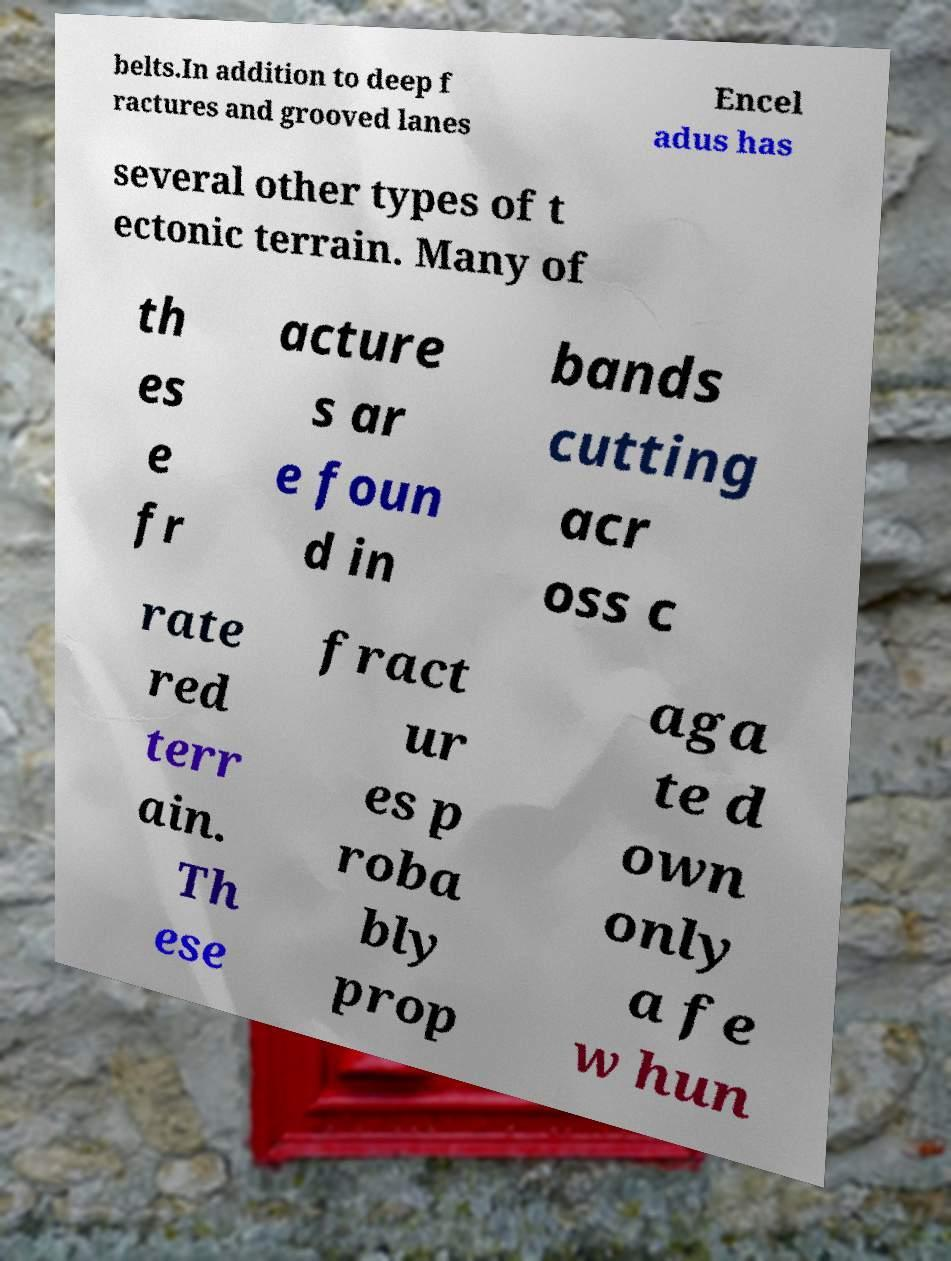For documentation purposes, I need the text within this image transcribed. Could you provide that? belts.In addition to deep f ractures and grooved lanes Encel adus has several other types of t ectonic terrain. Many of th es e fr acture s ar e foun d in bands cutting acr oss c rate red terr ain. Th ese fract ur es p roba bly prop aga te d own only a fe w hun 